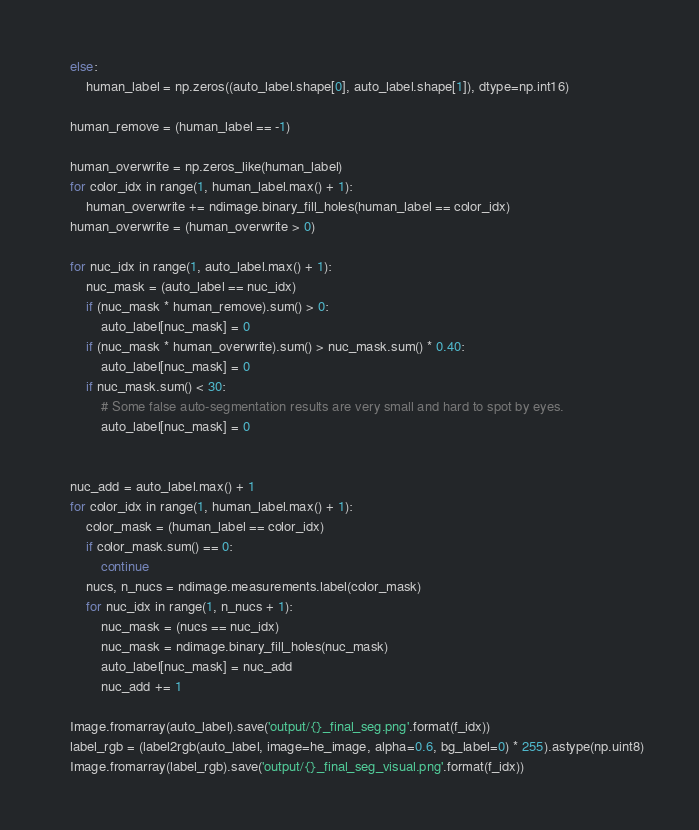<code> <loc_0><loc_0><loc_500><loc_500><_Python_>    else:
        human_label = np.zeros((auto_label.shape[0], auto_label.shape[1]), dtype=np.int16)

    human_remove = (human_label == -1)

    human_overwrite = np.zeros_like(human_label)
    for color_idx in range(1, human_label.max() + 1):
        human_overwrite += ndimage.binary_fill_holes(human_label == color_idx)
    human_overwrite = (human_overwrite > 0)

    for nuc_idx in range(1, auto_label.max() + 1):
        nuc_mask = (auto_label == nuc_idx)
        if (nuc_mask * human_remove).sum() > 0:
            auto_label[nuc_mask] = 0
        if (nuc_mask * human_overwrite).sum() > nuc_mask.sum() * 0.40:
            auto_label[nuc_mask] = 0
        if nuc_mask.sum() < 30:
            # Some false auto-segmentation results are very small and hard to spot by eyes.
            auto_label[nuc_mask] = 0


    nuc_add = auto_label.max() + 1
    for color_idx in range(1, human_label.max() + 1):
        color_mask = (human_label == color_idx)
        if color_mask.sum() == 0:
            continue
        nucs, n_nucs = ndimage.measurements.label(color_mask)
        for nuc_idx in range(1, n_nucs + 1):
            nuc_mask = (nucs == nuc_idx)
            nuc_mask = ndimage.binary_fill_holes(nuc_mask)
            auto_label[nuc_mask] = nuc_add
            nuc_add += 1

    Image.fromarray(auto_label).save('output/{}_final_seg.png'.format(f_idx))
    label_rgb = (label2rgb(auto_label, image=he_image, alpha=0.6, bg_label=0) * 255).astype(np.uint8)
    Image.fromarray(label_rgb).save('output/{}_final_seg_visual.png'.format(f_idx))

</code> 